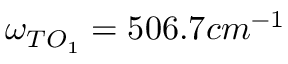<formula> <loc_0><loc_0><loc_500><loc_500>\omega _ { T O _ { 1 } } = 5 0 6 . 7 c m ^ { - 1 }</formula> 